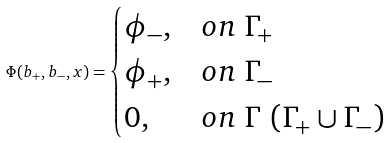<formula> <loc_0><loc_0><loc_500><loc_500>\Phi ( b _ { + } , b _ { - } , x ) = \begin{cases} \phi _ { - } , & o n \ \Gamma _ { + } \\ \phi _ { + } , & o n \ \Gamma _ { - } \\ 0 , & o n \ \Gamma \ ( \Gamma _ { + } \cup \Gamma _ { - } ) \end{cases}</formula> 